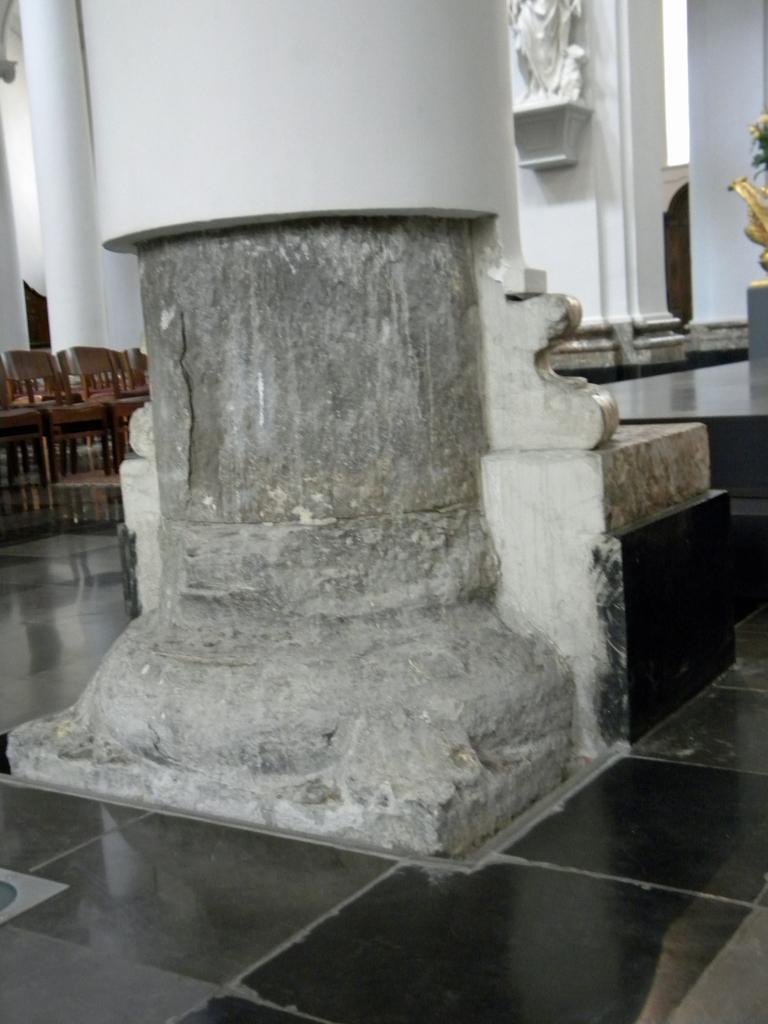Describe this image in one or two sentences. In this image we can see a pillar. In the back there are chairs. On the wall there is a sculpture. 